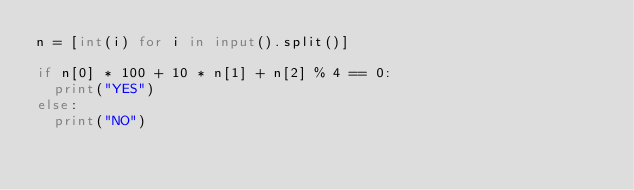<code> <loc_0><loc_0><loc_500><loc_500><_Python_>n = [int(i) for i in input().split()]

if n[0] * 100 + 10 * n[1] + n[2] % 4 == 0:
  print("YES")
else:
  print("NO")</code> 